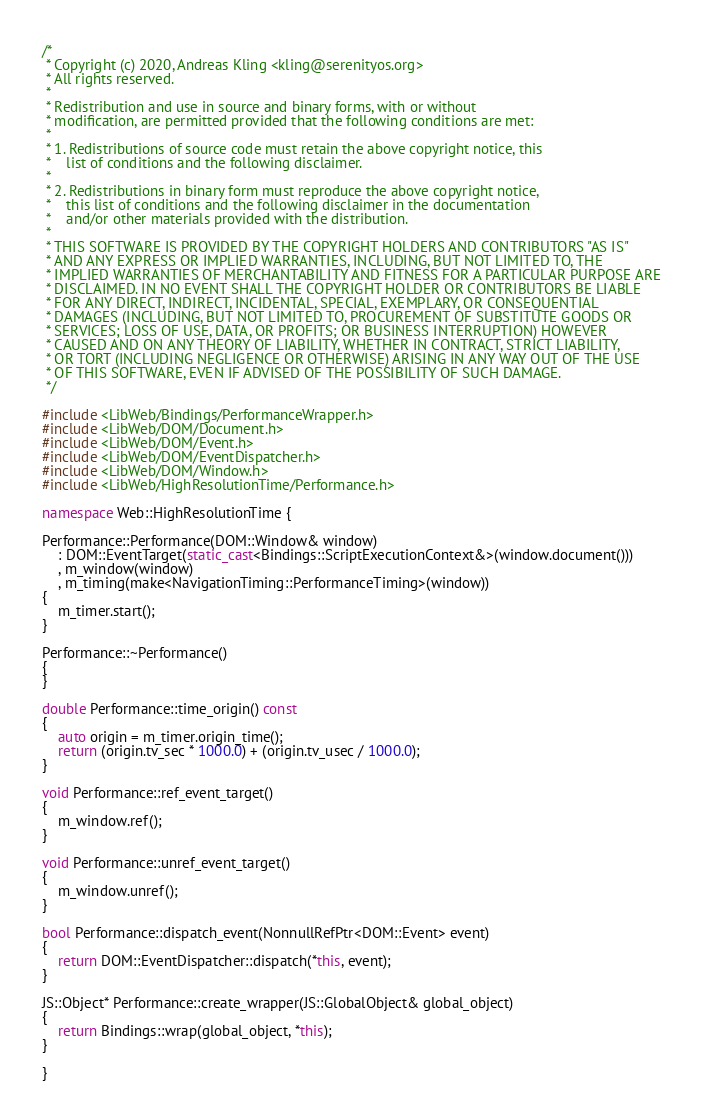<code> <loc_0><loc_0><loc_500><loc_500><_C++_>/*
 * Copyright (c) 2020, Andreas Kling <kling@serenityos.org>
 * All rights reserved.
 *
 * Redistribution and use in source and binary forms, with or without
 * modification, are permitted provided that the following conditions are met:
 *
 * 1. Redistributions of source code must retain the above copyright notice, this
 *    list of conditions and the following disclaimer.
 *
 * 2. Redistributions in binary form must reproduce the above copyright notice,
 *    this list of conditions and the following disclaimer in the documentation
 *    and/or other materials provided with the distribution.
 *
 * THIS SOFTWARE IS PROVIDED BY THE COPYRIGHT HOLDERS AND CONTRIBUTORS "AS IS"
 * AND ANY EXPRESS OR IMPLIED WARRANTIES, INCLUDING, BUT NOT LIMITED TO, THE
 * IMPLIED WARRANTIES OF MERCHANTABILITY AND FITNESS FOR A PARTICULAR PURPOSE ARE
 * DISCLAIMED. IN NO EVENT SHALL THE COPYRIGHT HOLDER OR CONTRIBUTORS BE LIABLE
 * FOR ANY DIRECT, INDIRECT, INCIDENTAL, SPECIAL, EXEMPLARY, OR CONSEQUENTIAL
 * DAMAGES (INCLUDING, BUT NOT LIMITED TO, PROCUREMENT OF SUBSTITUTE GOODS OR
 * SERVICES; LOSS OF USE, DATA, OR PROFITS; OR BUSINESS INTERRUPTION) HOWEVER
 * CAUSED AND ON ANY THEORY OF LIABILITY, WHETHER IN CONTRACT, STRICT LIABILITY,
 * OR TORT (INCLUDING NEGLIGENCE OR OTHERWISE) ARISING IN ANY WAY OUT OF THE USE
 * OF THIS SOFTWARE, EVEN IF ADVISED OF THE POSSIBILITY OF SUCH DAMAGE.
 */

#include <LibWeb/Bindings/PerformanceWrapper.h>
#include <LibWeb/DOM/Document.h>
#include <LibWeb/DOM/Event.h>
#include <LibWeb/DOM/EventDispatcher.h>
#include <LibWeb/DOM/Window.h>
#include <LibWeb/HighResolutionTime/Performance.h>

namespace Web::HighResolutionTime {

Performance::Performance(DOM::Window& window)
    : DOM::EventTarget(static_cast<Bindings::ScriptExecutionContext&>(window.document()))
    , m_window(window)
    , m_timing(make<NavigationTiming::PerformanceTiming>(window))
{
    m_timer.start();
}

Performance::~Performance()
{
}

double Performance::time_origin() const
{
    auto origin = m_timer.origin_time();
    return (origin.tv_sec * 1000.0) + (origin.tv_usec / 1000.0);
}

void Performance::ref_event_target()
{
    m_window.ref();
}

void Performance::unref_event_target()
{
    m_window.unref();
}

bool Performance::dispatch_event(NonnullRefPtr<DOM::Event> event)
{
    return DOM::EventDispatcher::dispatch(*this, event);
}

JS::Object* Performance::create_wrapper(JS::GlobalObject& global_object)
{
    return Bindings::wrap(global_object, *this);
}

}
</code> 